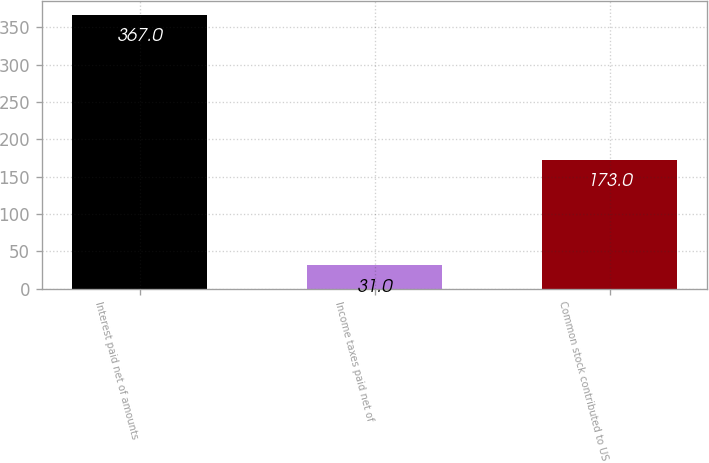Convert chart to OTSL. <chart><loc_0><loc_0><loc_500><loc_500><bar_chart><fcel>Interest paid net of amounts<fcel>Income taxes paid net of<fcel>Common stock contributed to US<nl><fcel>367<fcel>31<fcel>173<nl></chart> 